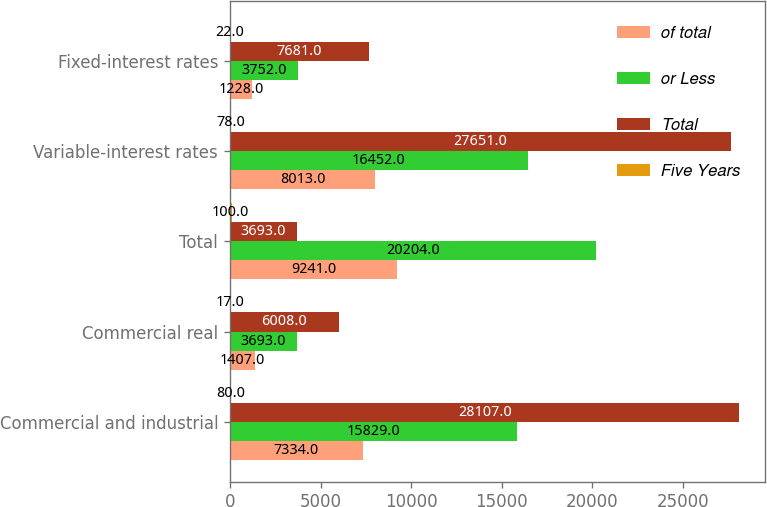Convert chart. <chart><loc_0><loc_0><loc_500><loc_500><stacked_bar_chart><ecel><fcel>Commercial and industrial<fcel>Commercial real<fcel>Total<fcel>Variable-interest rates<fcel>Fixed-interest rates<nl><fcel>of total<fcel>7334<fcel>1407<fcel>9241<fcel>8013<fcel>1228<nl><fcel>or Less<fcel>15829<fcel>3693<fcel>20204<fcel>16452<fcel>3752<nl><fcel>Total<fcel>28107<fcel>6008<fcel>3693<fcel>27651<fcel>7681<nl><fcel>Five Years<fcel>80<fcel>17<fcel>100<fcel>78<fcel>22<nl></chart> 